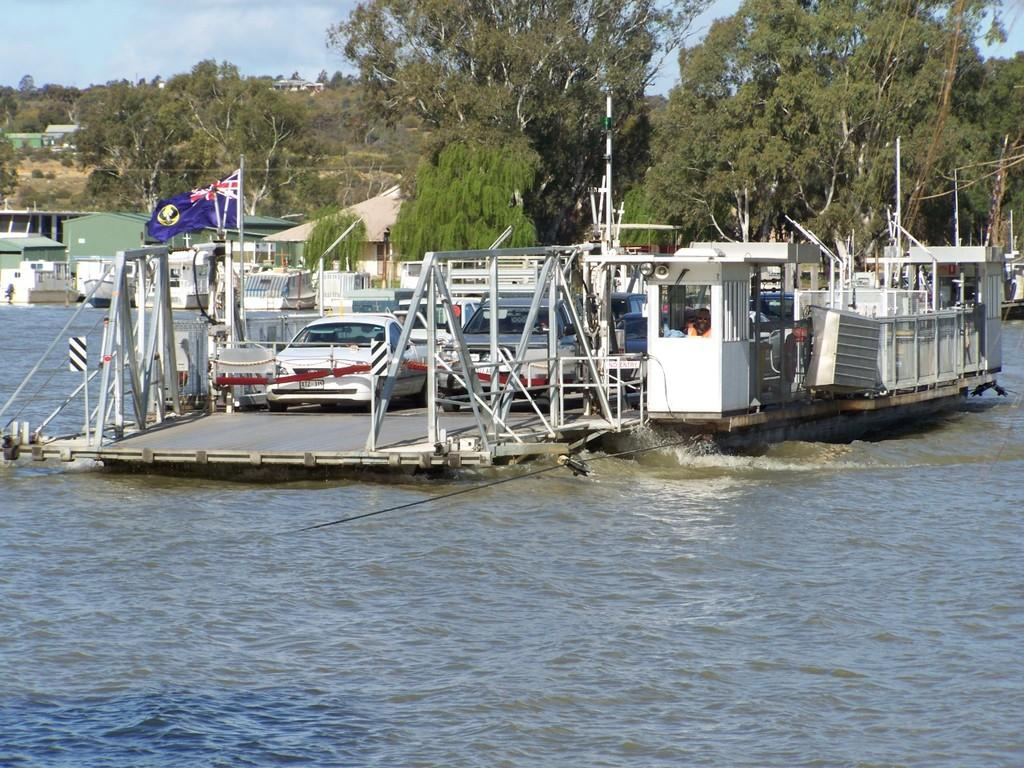What is the main subject of the image? The main subject of the image is a boat. What other vehicles are present in the image? There are cars in the image. What structures can be seen in the image? There are poles and flags in the image. What type of natural environment is visible in the image? There are watersheds and trees in the image. What is visible in the background of the image? The sky is visible in the background of the image. What type of hope can be seen growing on the branch in the image? There is no hope or branch present in the image. 